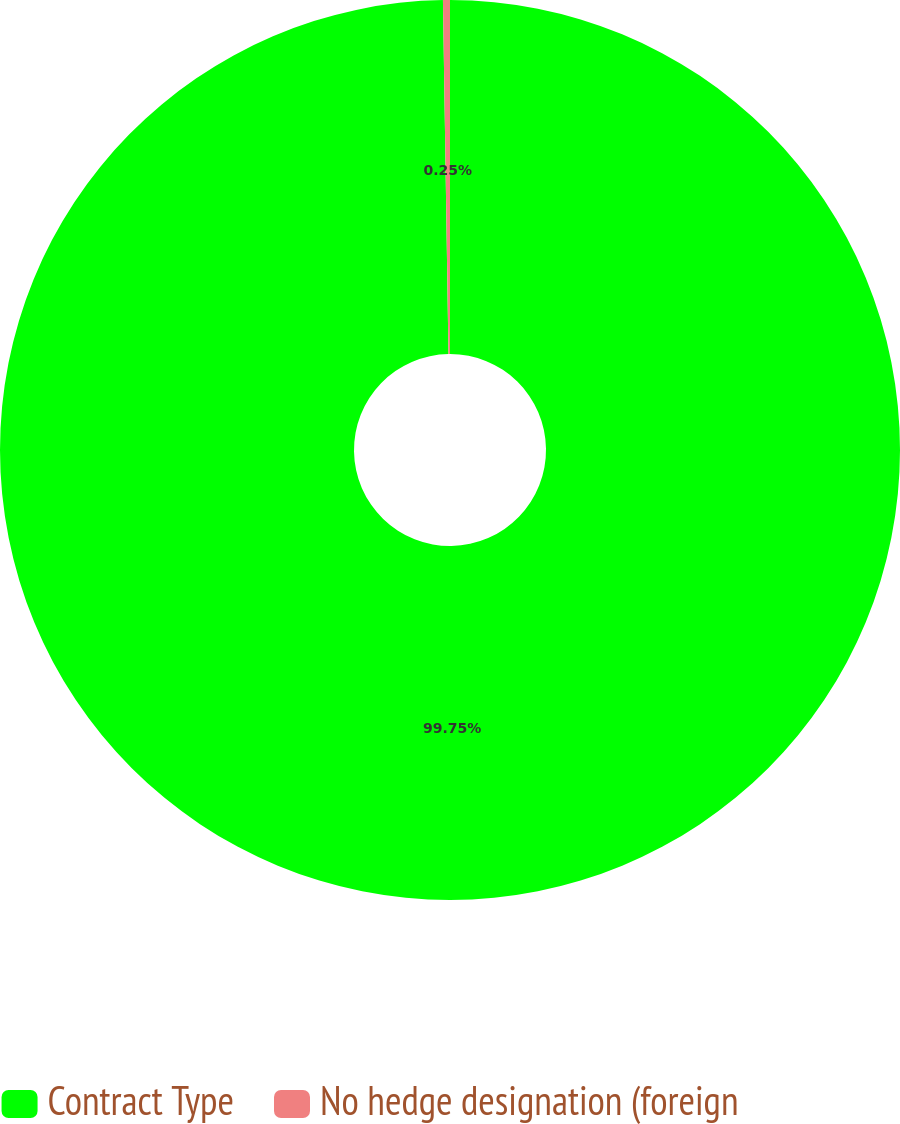<chart> <loc_0><loc_0><loc_500><loc_500><pie_chart><fcel>Contract Type<fcel>No hedge designation (foreign<nl><fcel>99.75%<fcel>0.25%<nl></chart> 